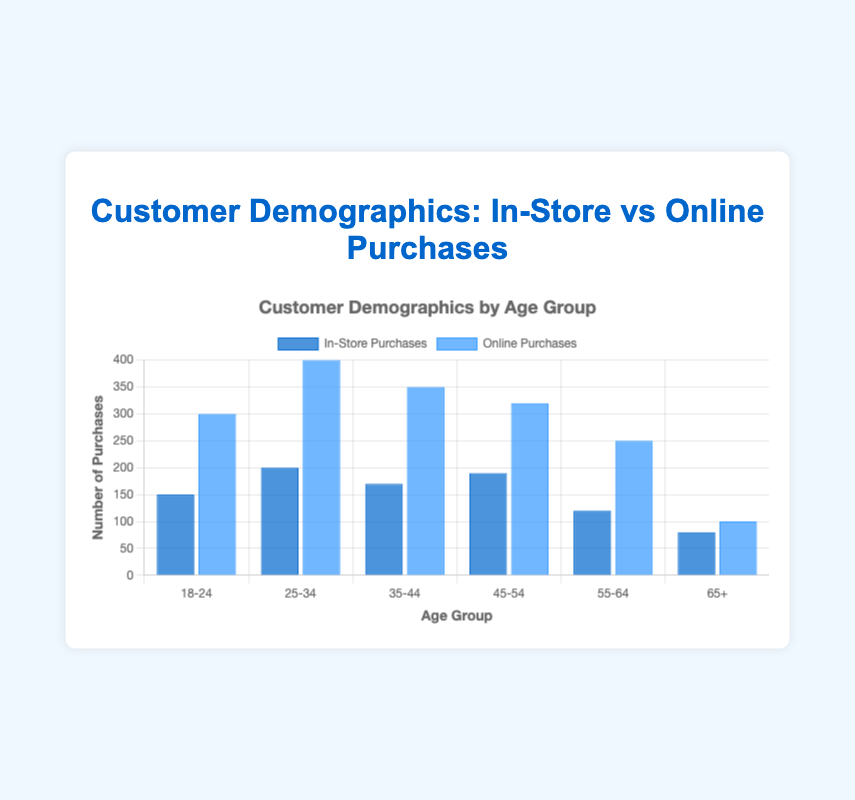Which age group has the highest number of online purchases? The age group with the highest number of online purchases is identified by comparing the values for online purchases across all age groups. The 25-34 age group has the highest value of 400 online purchases.
Answer: 25-34 What is the total number of in-store purchases for the age groups 18-24 and 25-34 combined? Add the in-store purchases for age groups 18-24 (150) and 25-34 (200), which gives 150 + 200 = 350.
Answer: 350 How does the number of online purchases for the 35-44 age group compare to their in-store purchases? Compare the values of online and in-store purchases for the 35-44 age group. The online purchases are 350, while the in-store purchases are 170.
Answer: Online purchases are more Which age group has the smallest difference between in-store and online purchases? Calculate the difference between online and in-store purchases for all age groups and determine the smallest difference. The differences are: 18-24 (150), 25-34 (200), 35-44 (180), 45-54 (130), 55-64 (130), 65+ (20). The age group 65+ has the smallest difference.
Answer: 65+ What is the average number of purchases for the age group 45-54 when considering both in-store and online purchases? Calculate the average by adding in-store (190) and online (320) purchases for the 45-54 age group, then divide by 2: (190 + 320) / 2 = 255.
Answer: 255 Which age groups have more online purchases than the average online purchases across all age groups? First, calculate the average online purchases across all age groups: (300 + 400 + 350 + 320 + 250 + 100) / 6 = 286.7. Age groups 18-24 (300), 25-34 (400), 35-44 (350), and 45-54 (320) have more than 286.7 online purchases.
Answer: 18-24, 25-34, 35-44, 45-54 What is the total number of purchases (both in-store and online) for the age group 55-64? Add the in-store (120) and online (250) purchases for the age group 55-64: 120 + 250 = 370.
Answer: 370 Among all age groups, which one has the highest combined total of in-store and online purchases? Sum the in-store and online purchases for each age group and compare to find the highest. 25-34 has 200 (in-store) + 400 (online) = 600, which is the highest combined total.
Answer: 25-34 